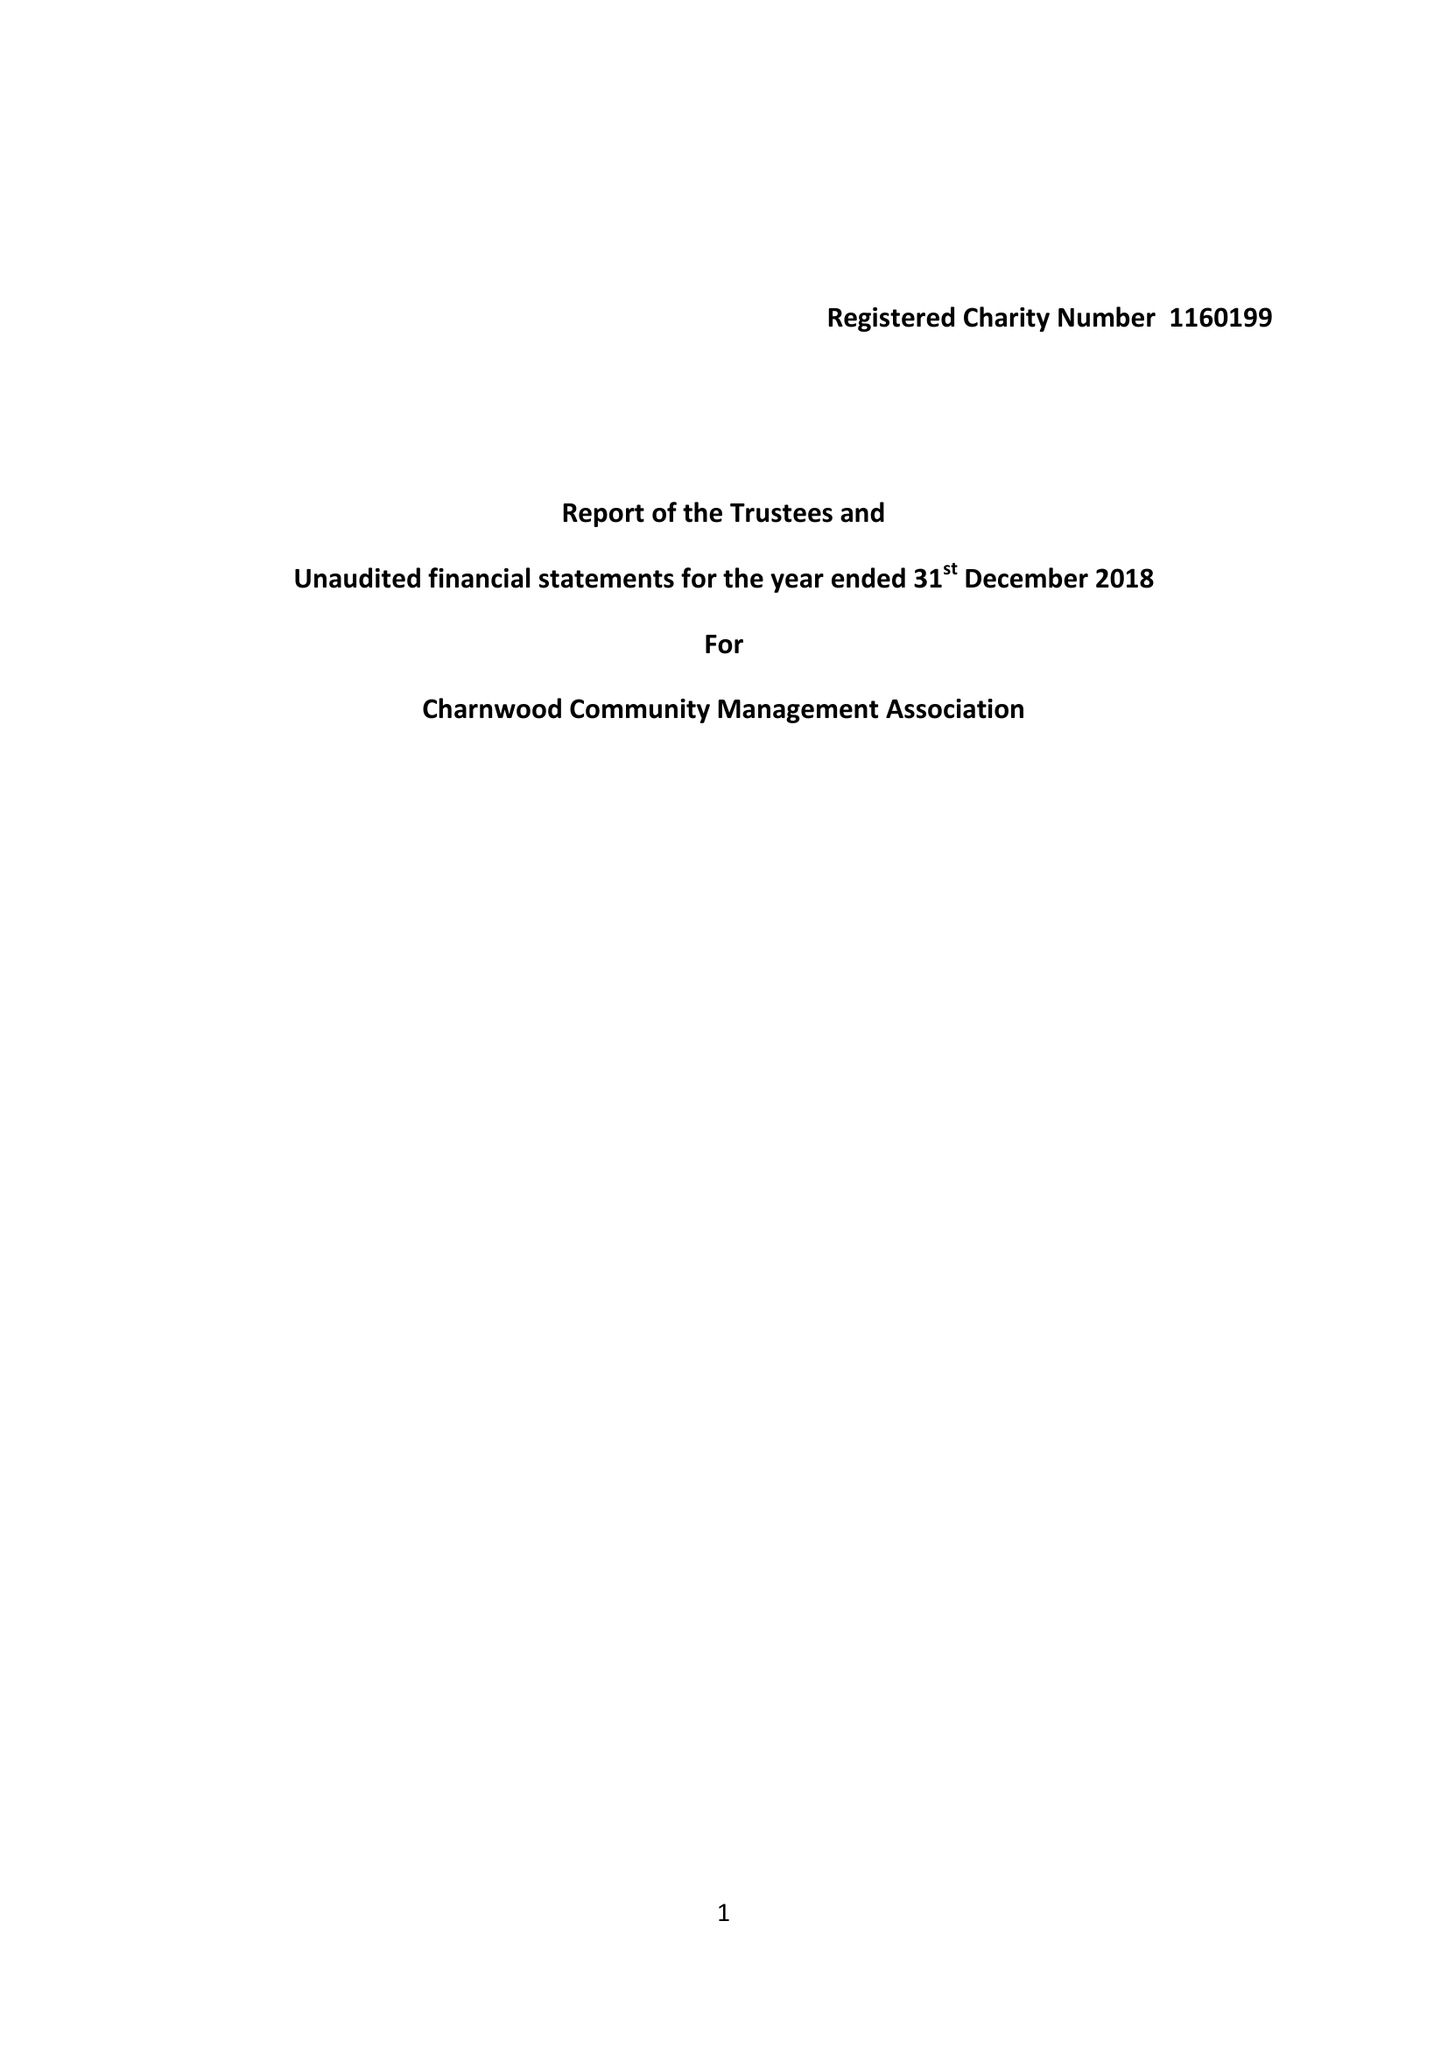What is the value for the spending_annually_in_british_pounds?
Answer the question using a single word or phrase. 22.00 